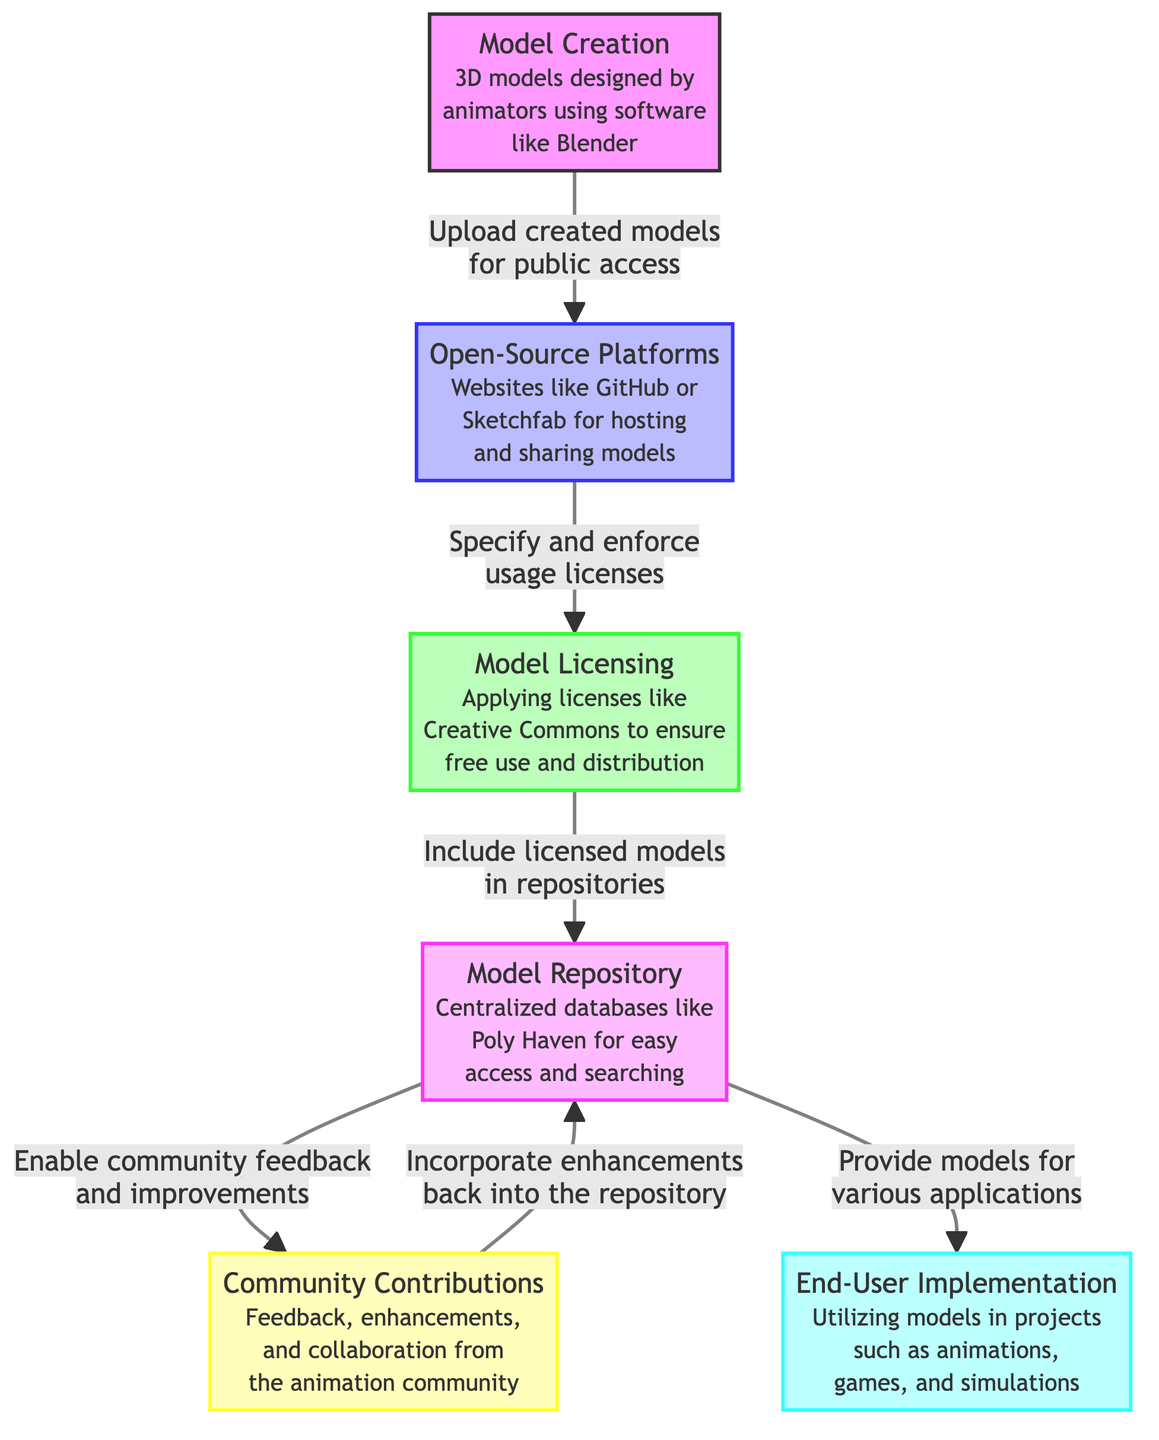What is the first step in the open-source model distribution process? The diagram starts with "Model Creation," indicating that this is the initial step where 3D models are designed by animators using software like Blender.
Answer: Model Creation Which platforms are mentioned for hosting and sharing models? The diagram specifically notes "Open-Source Platforms" such as GitHub or Sketchfab where models can be hosted and shared.
Answer: GitHub or Sketchfab What is the purpose of the "Model Licensing" node? This node indicates that the purpose is to specify and enforce usage licenses, which is crucial for ensuring models can be used and distributed freely.
Answer: Specify and enforce usage licenses How many community contributions are stated in the flowchart? The diagram includes one node labeled "Community Contributions," which illustrates feedback, enhancements, and collaboration from the animation community.
Answer: One What action occurs after models are included in repositories? After including licensed models in repositories, the flowchart shows that this enables community feedback and improvements, illustrating how the repository interacts with the community.
Answer: Enable community feedback and improvements What do end-users do with the models? According to the diagram, end users utilize the models in projects such as animations, games, and simulations, which reflects how the final consumers interact with the created content.
Answer: Utilize models How does community feedback relate to the model repository? The diagram indicates that community feedback is incorporated back into the repository for enhancements, creating a cyclical process where feedback leads to improvements being added to the models.
Answer: Incorporate enhancements back into the repository Which step directly follows the "Open-Source Platforms" node? The next node after "Open-Source Platforms" is "Model Licensing," indicating that after models are shared, licenses are specified and enforced to govern their use.
Answer: Model Licensing Which entities are involved in providing models for various applications? The node "Model Repository" specifies that it provides models for various applications, directly linking to the utility of models for different projects such as animations and simulations.
Answer: Model Repository 